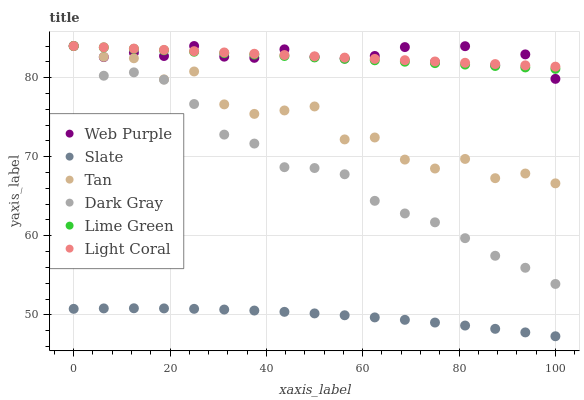Does Slate have the minimum area under the curve?
Answer yes or no. Yes. Does Web Purple have the maximum area under the curve?
Answer yes or no. Yes. Does Dark Gray have the minimum area under the curve?
Answer yes or no. No. Does Dark Gray have the maximum area under the curve?
Answer yes or no. No. Is Lime Green the smoothest?
Answer yes or no. Yes. Is Tan the roughest?
Answer yes or no. Yes. Is Slate the smoothest?
Answer yes or no. No. Is Slate the roughest?
Answer yes or no. No. Does Slate have the lowest value?
Answer yes or no. Yes. Does Dark Gray have the lowest value?
Answer yes or no. No. Does Lime Green have the highest value?
Answer yes or no. Yes. Does Slate have the highest value?
Answer yes or no. No. Is Slate less than Dark Gray?
Answer yes or no. Yes. Is Dark Gray greater than Slate?
Answer yes or no. Yes. Does Tan intersect Web Purple?
Answer yes or no. Yes. Is Tan less than Web Purple?
Answer yes or no. No. Is Tan greater than Web Purple?
Answer yes or no. No. Does Slate intersect Dark Gray?
Answer yes or no. No. 